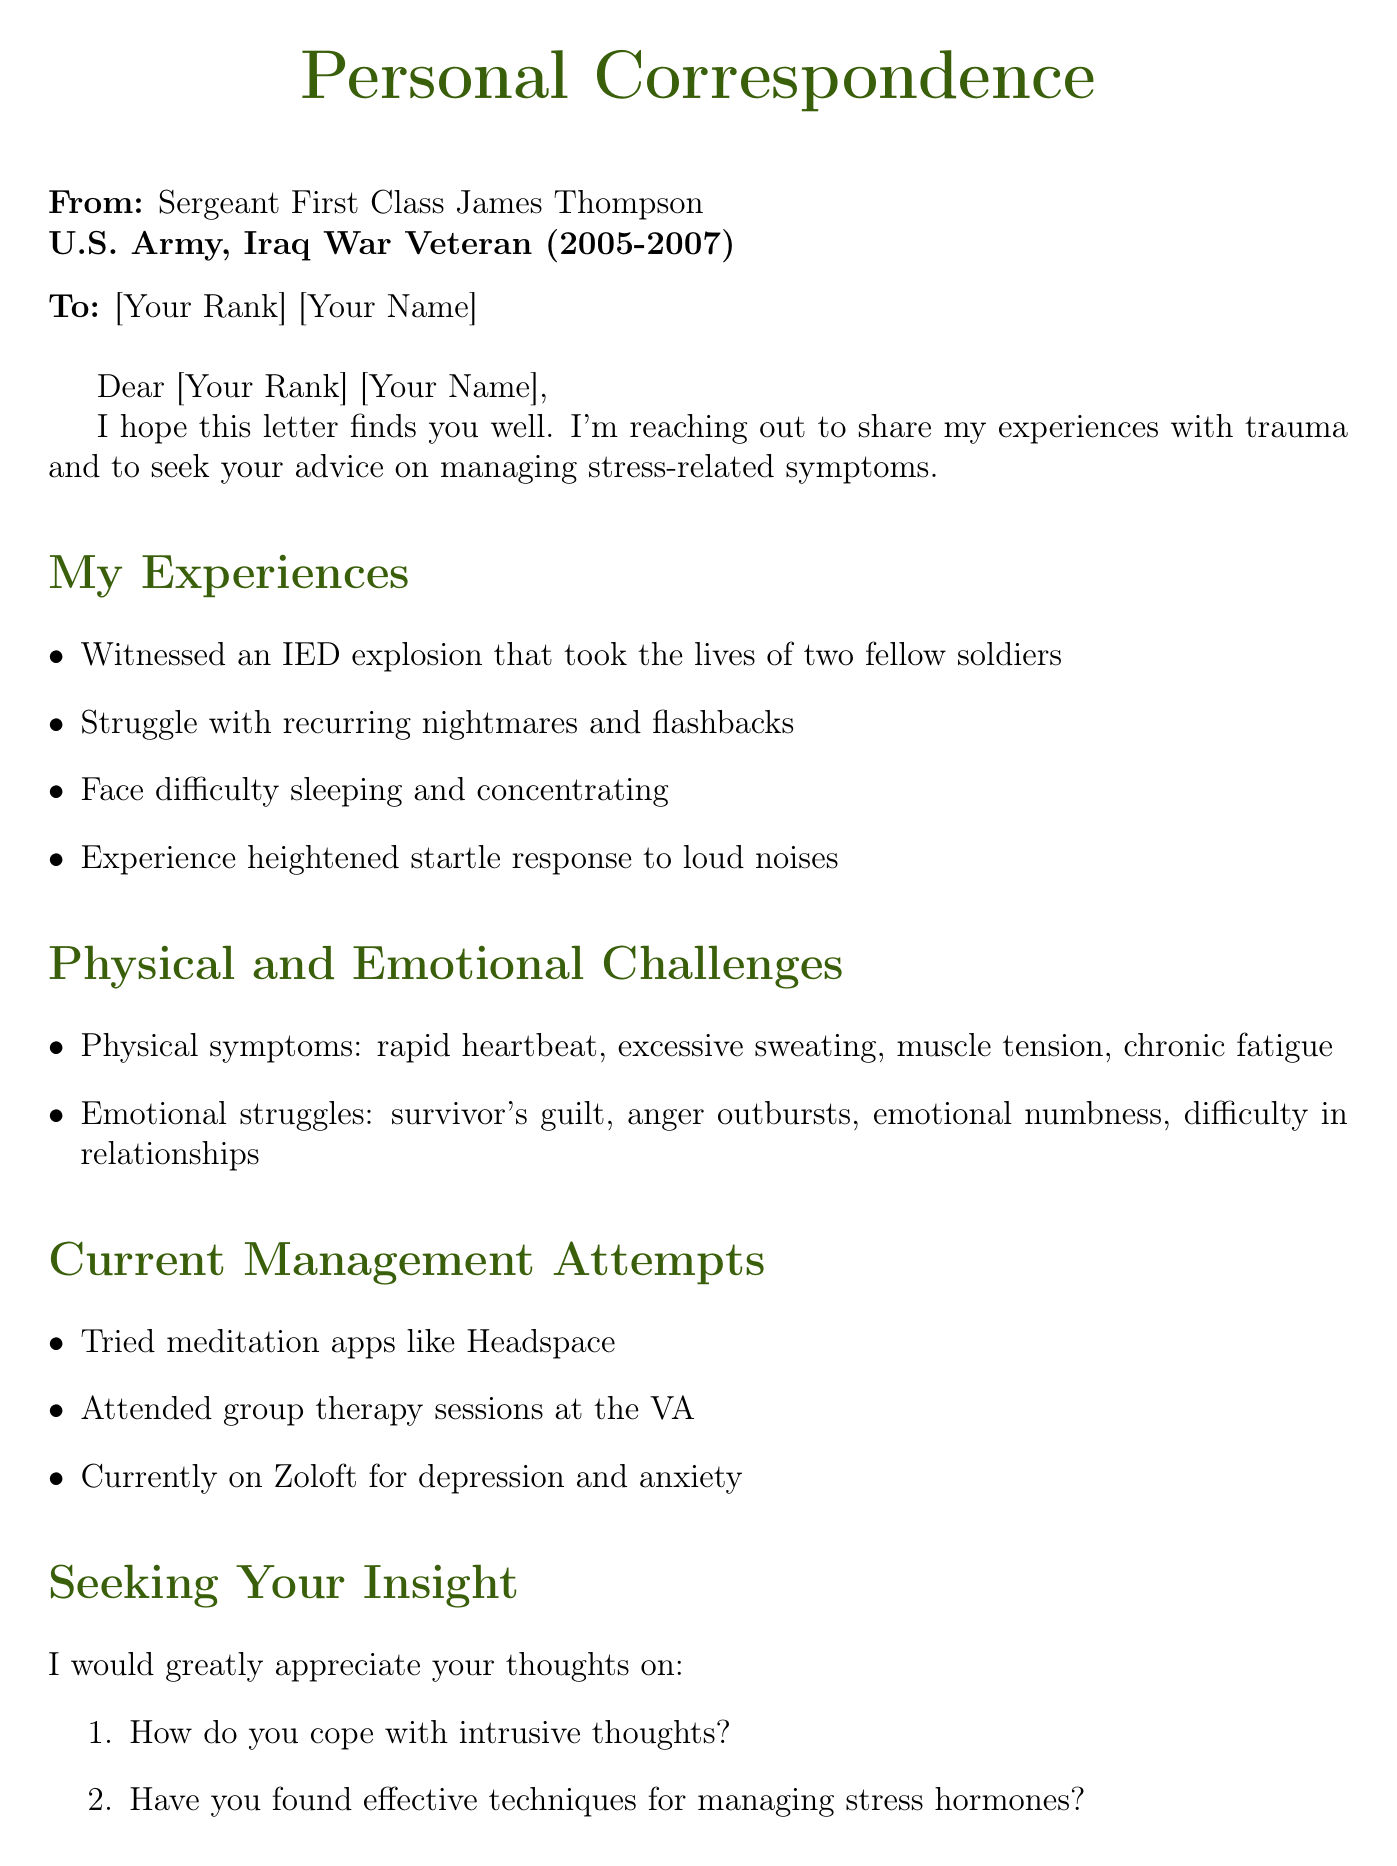What is the sender's name? The sender's name is listed at the beginning of the document.
Answer: James Thompson What military rank does the sender hold? The sender's rank is specified right below their name.
Answer: Sergeant First Class What deployment is the sender associated with? The deployment period is mentioned in the sender's introduction.
Answer: Iraq War, 2005-2007 What physical symptom is mentioned in connection with stress? The physical symptoms are listed in a specific section of the document.
Answer: Rapid heartbeat What emotional challenge does the sender experience? The emotional challenges are outlined clearly in a bullet list.
Answer: Survivor's guilt How does the sender manage stress? The management attempts are described in a list format.
Answer: Attended group therapy sessions at the VA What technique does the sender mention trying? The specific technique tried by the sender is highlighted in the management attempts.
Answer: Meditation apps like Headspace How many fellow soldiers did the sender lose in combat? The number of soldiers lost is mentioned in the sender's experiences.
Answer: Two What type of medication is the sender currently prescribed? The medication is stated in the current management attempts section.
Answer: Zoloft What is the closing sentiment expressed by the sender? The closing remarks express the sender's feelings towards the recipient's story.
Answer: Thank you for sharing your story 